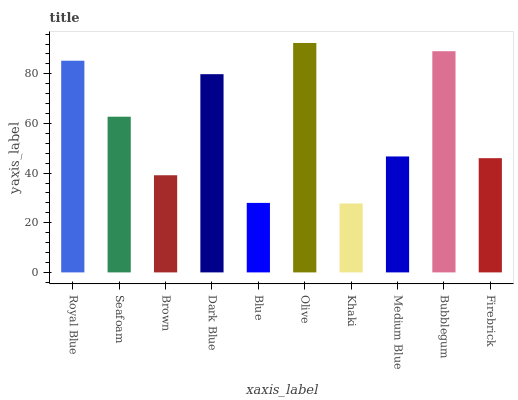Is Khaki the minimum?
Answer yes or no. Yes. Is Olive the maximum?
Answer yes or no. Yes. Is Seafoam the minimum?
Answer yes or no. No. Is Seafoam the maximum?
Answer yes or no. No. Is Royal Blue greater than Seafoam?
Answer yes or no. Yes. Is Seafoam less than Royal Blue?
Answer yes or no. Yes. Is Seafoam greater than Royal Blue?
Answer yes or no. No. Is Royal Blue less than Seafoam?
Answer yes or no. No. Is Seafoam the high median?
Answer yes or no. Yes. Is Medium Blue the low median?
Answer yes or no. Yes. Is Medium Blue the high median?
Answer yes or no. No. Is Blue the low median?
Answer yes or no. No. 